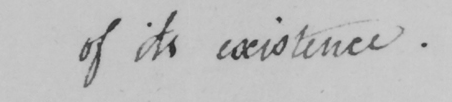Please provide the text content of this handwritten line. of its existence . 